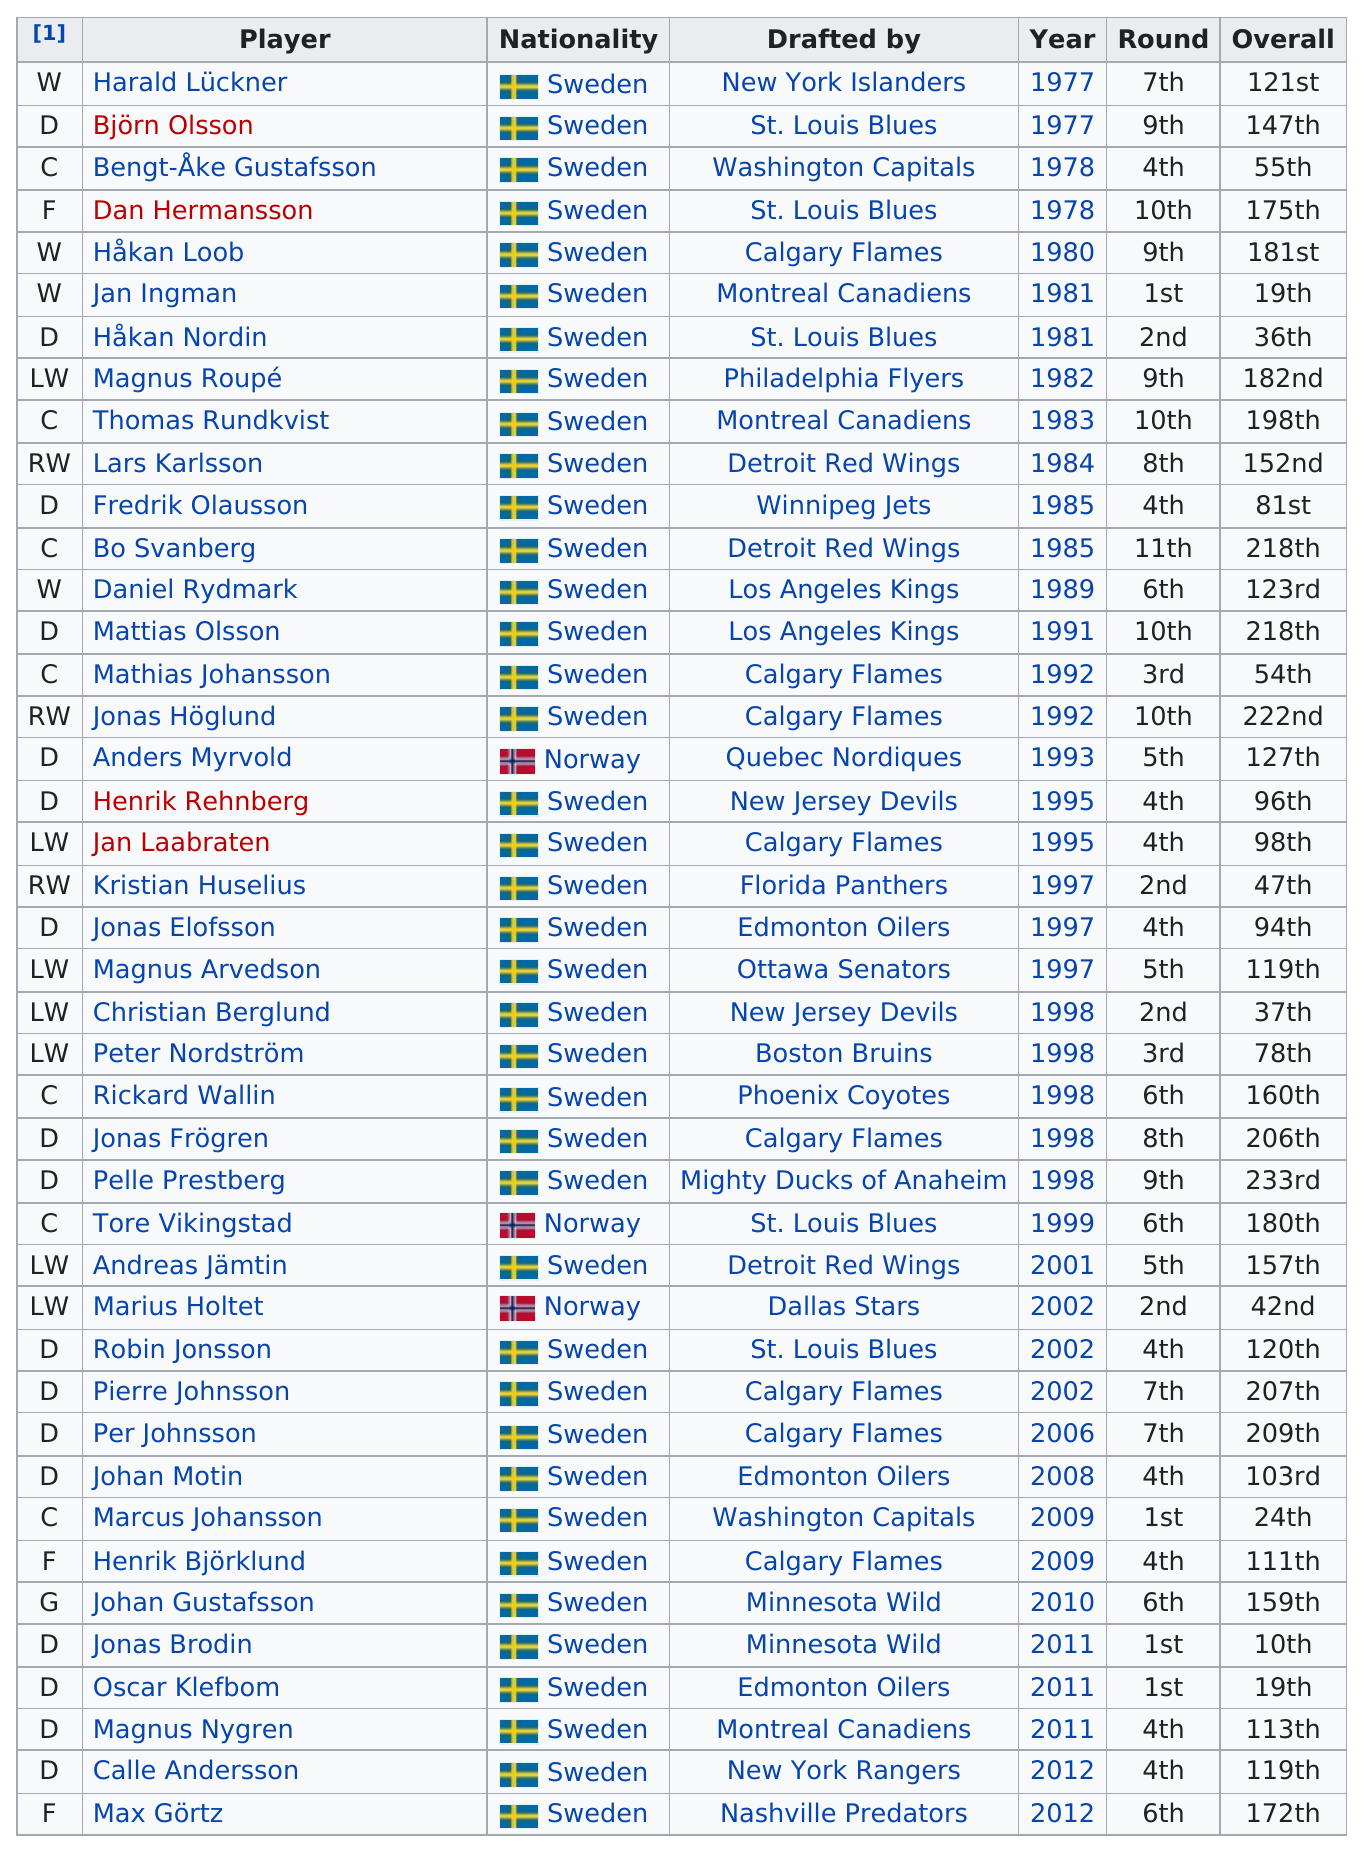Specify some key components in this picture. Anders Myrvold was the first player from Norway who was drafted. The St. Louis Blues drafted a total of five players. Anders Myrvold shares the same nationality as Tore Vikingstad and Marius Holtet. A total of 4 players were drafted in the first round. Håkan Nordin is the player who is listed next after Jan Ingman. 